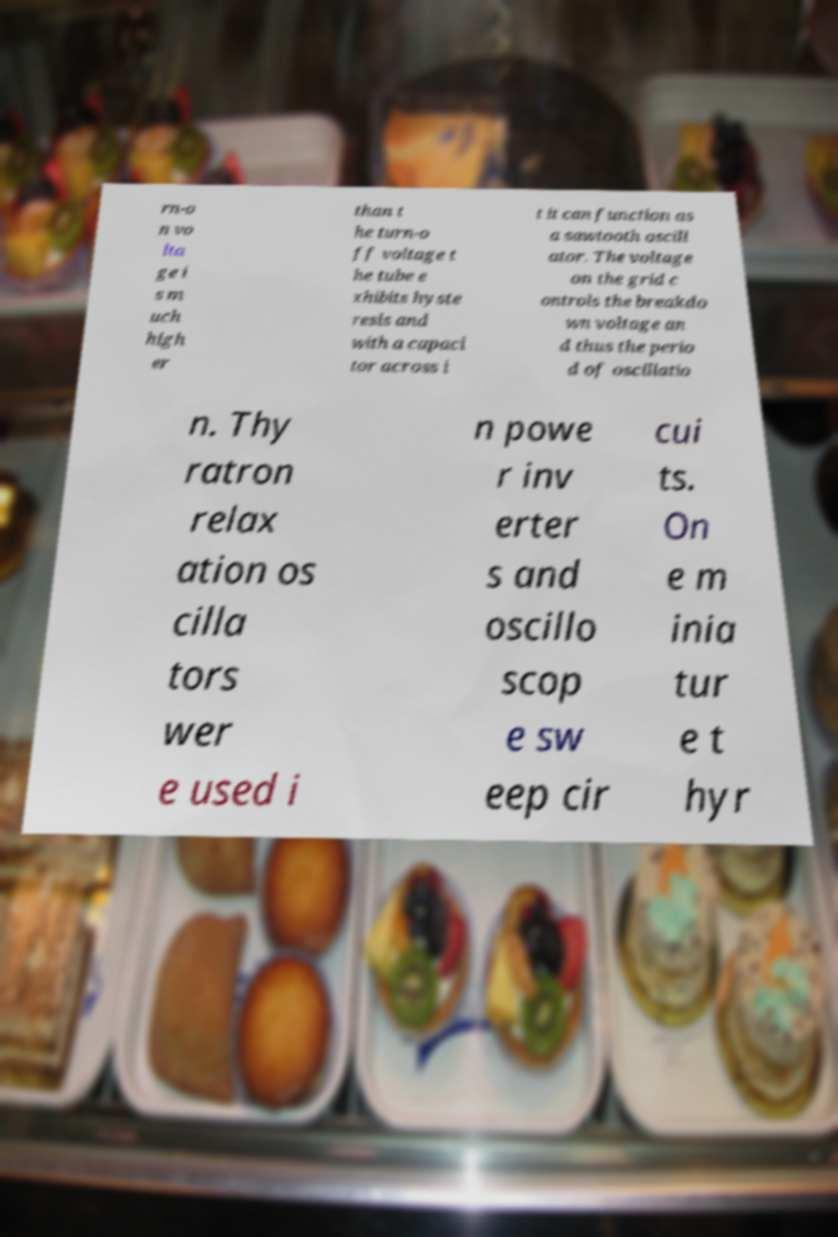Please read and relay the text visible in this image. What does it say? rn-o n vo lta ge i s m uch high er than t he turn-o ff voltage t he tube e xhibits hyste resis and with a capaci tor across i t it can function as a sawtooth oscill ator. The voltage on the grid c ontrols the breakdo wn voltage an d thus the perio d of oscillatio n. Thy ratron relax ation os cilla tors wer e used i n powe r inv erter s and oscillo scop e sw eep cir cui ts. On e m inia tur e t hyr 